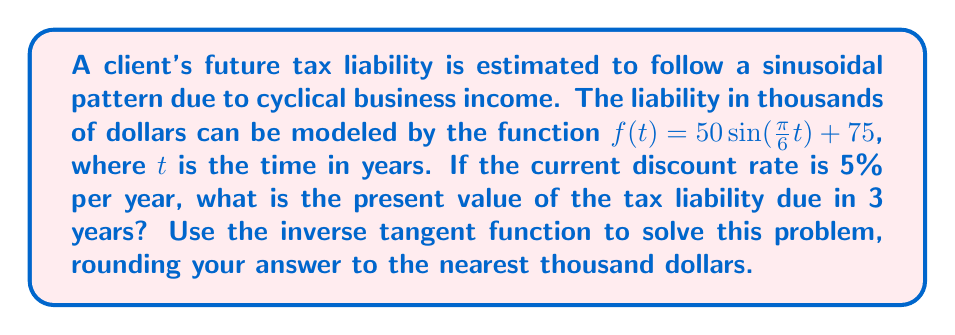Give your solution to this math problem. To solve this problem, we'll follow these steps:

1) First, we need to find the tax liability at $t = 3$ years:

   $f(3) = 50 \sin(\frac{\pi}{6} \cdot 3) + 75$
   $= 50 \sin(\frac{\pi}{2}) + 75$
   $= 50 \cdot 1 + 75 = 125$ thousand dollars

2) Now, we need to calculate the present value of $125,000 due in 3 years with a 5% discount rate. The present value formula is:

   $PV = \frac{FV}{(1+r)^n}$

   Where $PV$ is present value, $FV$ is future value, $r$ is the discount rate, and $n$ is the number of years.

3) Plugging in our values:

   $PV = \frac{125}{(1+0.05)^3}$

4) To solve this using the inverse tangent function, we can rewrite this as:

   $PV = 125 \cdot (1.05)^{-3}$

5) Now, let's use the property: $x^{-n} = (\frac{1}{x})^n$

   $PV = 125 \cdot (\frac{1}{1.05})^3$

6) We can rewrite this as:

   $PV = 125 \cdot (\cos(\arctan(0.05)))^3$

   This is because $\frac{1}{\sqrt{1+x^2}} = \cos(\arctan(x))$

7) Calculate:

   $PV = 125 \cdot (\cos(\arctan(0.05)))^3$
   $\approx 125 \cdot (0.9988)^3$
   $\approx 125 \cdot 0.9964$
   $\approx 124.55$ thousand dollars

8) Rounding to the nearest thousand:

   $PV \approx 125$ thousand dollars
Answer: $125,000 